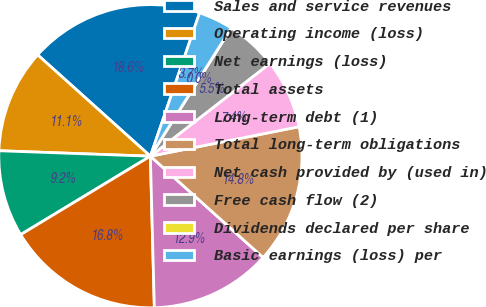<chart> <loc_0><loc_0><loc_500><loc_500><pie_chart><fcel>Sales and service revenues<fcel>Operating income (loss)<fcel>Net earnings (loss)<fcel>Total assets<fcel>Long-term debt (1)<fcel>Total long-term obligations<fcel>Net cash provided by (used in)<fcel>Free cash flow (2)<fcel>Dividends declared per share<fcel>Basic earnings (loss) per<nl><fcel>18.61%<fcel>11.08%<fcel>9.23%<fcel>16.76%<fcel>12.93%<fcel>14.77%<fcel>7.39%<fcel>5.54%<fcel>0.0%<fcel>3.69%<nl></chart> 